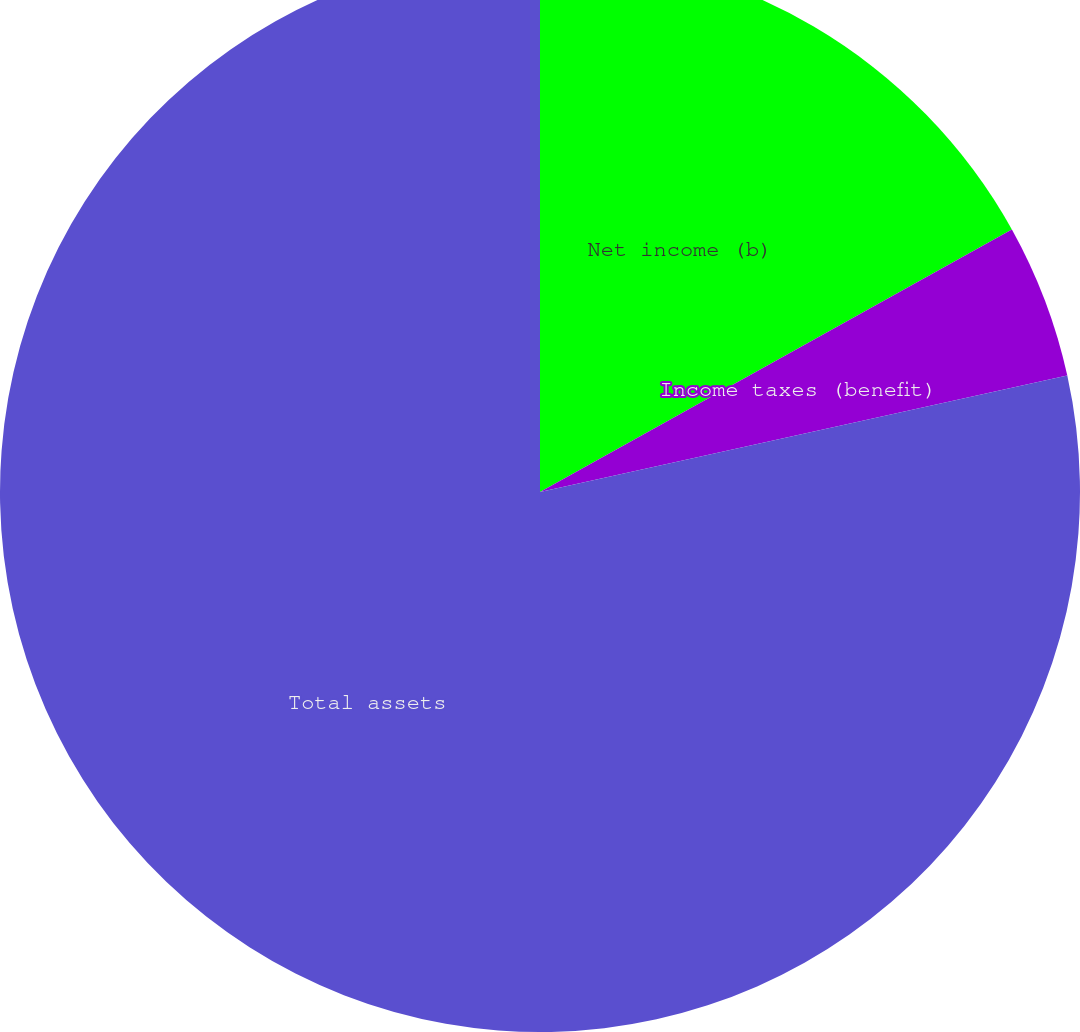<chart> <loc_0><loc_0><loc_500><loc_500><pie_chart><fcel>Net income (b)<fcel>Income taxes (benefit)<fcel>Total assets<nl><fcel>16.92%<fcel>4.62%<fcel>78.46%<nl></chart> 